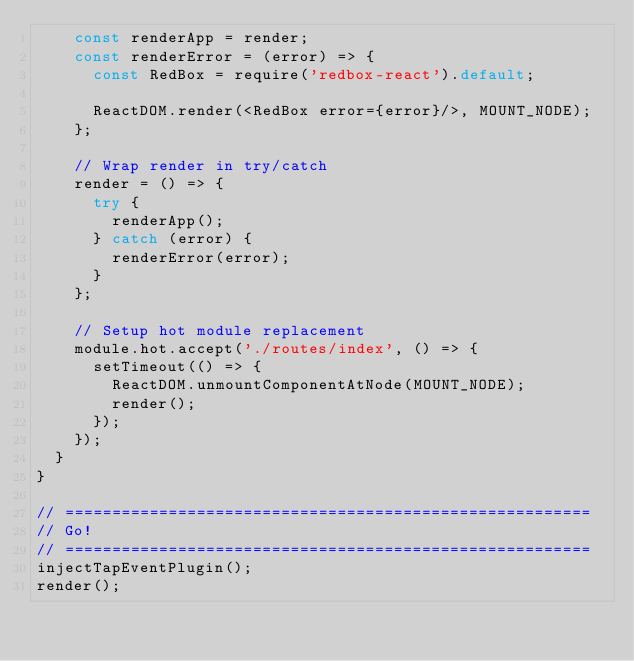Convert code to text. <code><loc_0><loc_0><loc_500><loc_500><_JavaScript_>    const renderApp = render;
    const renderError = (error) => {
      const RedBox = require('redbox-react').default;

      ReactDOM.render(<RedBox error={error}/>, MOUNT_NODE);
    };

    // Wrap render in try/catch
    render = () => {
      try {
        renderApp();
      } catch (error) {
        renderError(error);
      }
    };

    // Setup hot module replacement
    module.hot.accept('./routes/index', () => {
      setTimeout(() => {
        ReactDOM.unmountComponentAtNode(MOUNT_NODE);
        render();
      });
    });
  }
}

// ========================================================
// Go!
// ========================================================
injectTapEventPlugin();
render();
</code> 